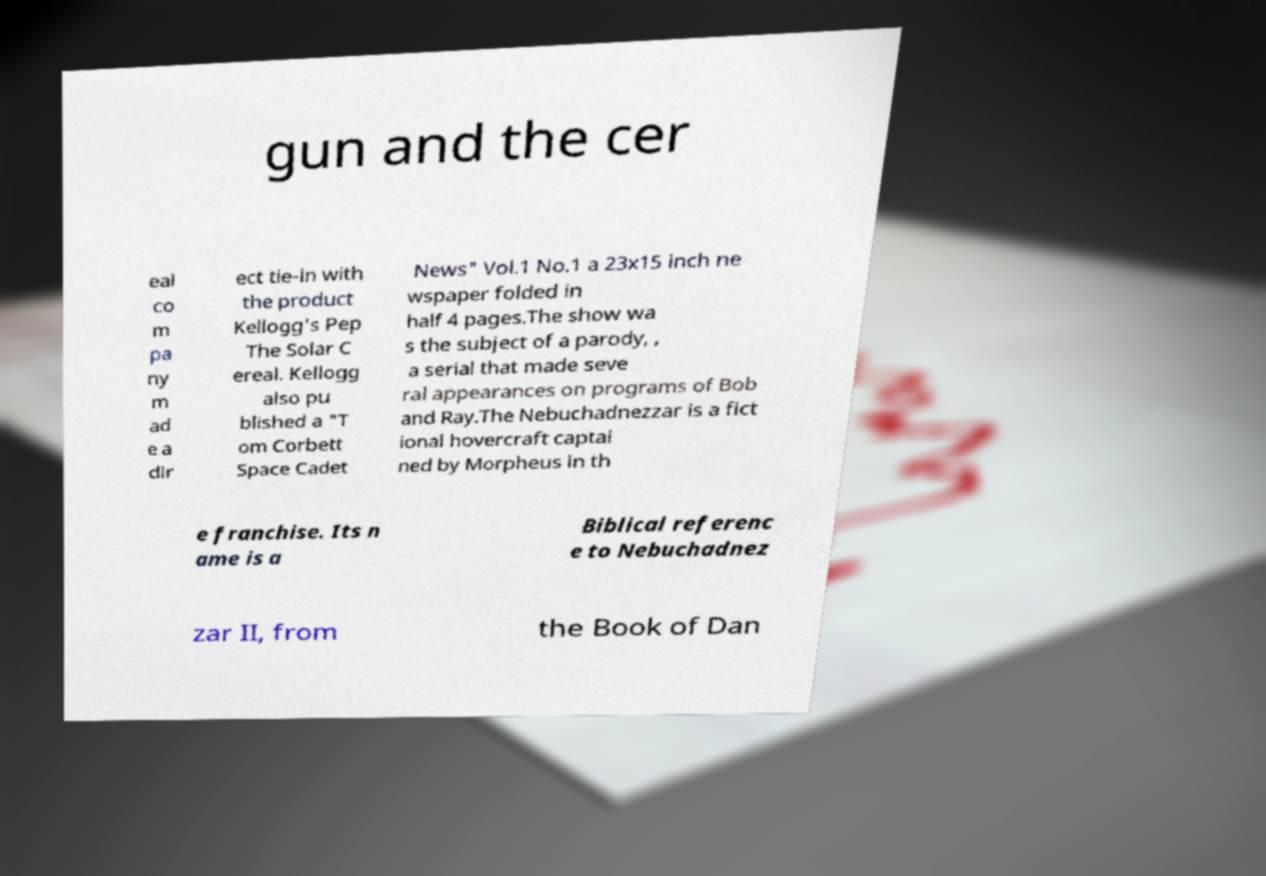Could you extract and type out the text from this image? gun and the cer eal co m pa ny m ad e a dir ect tie-in with the product Kellogg's Pep The Solar C ereal. Kellogg also pu blished a "T om Corbett Space Cadet News" Vol.1 No.1 a 23x15 inch ne wspaper folded in half 4 pages.The show wa s the subject of a parody, , a serial that made seve ral appearances on programs of Bob and Ray.The Nebuchadnezzar is a fict ional hovercraft captai ned by Morpheus in th e franchise. Its n ame is a Biblical referenc e to Nebuchadnez zar II, from the Book of Dan 